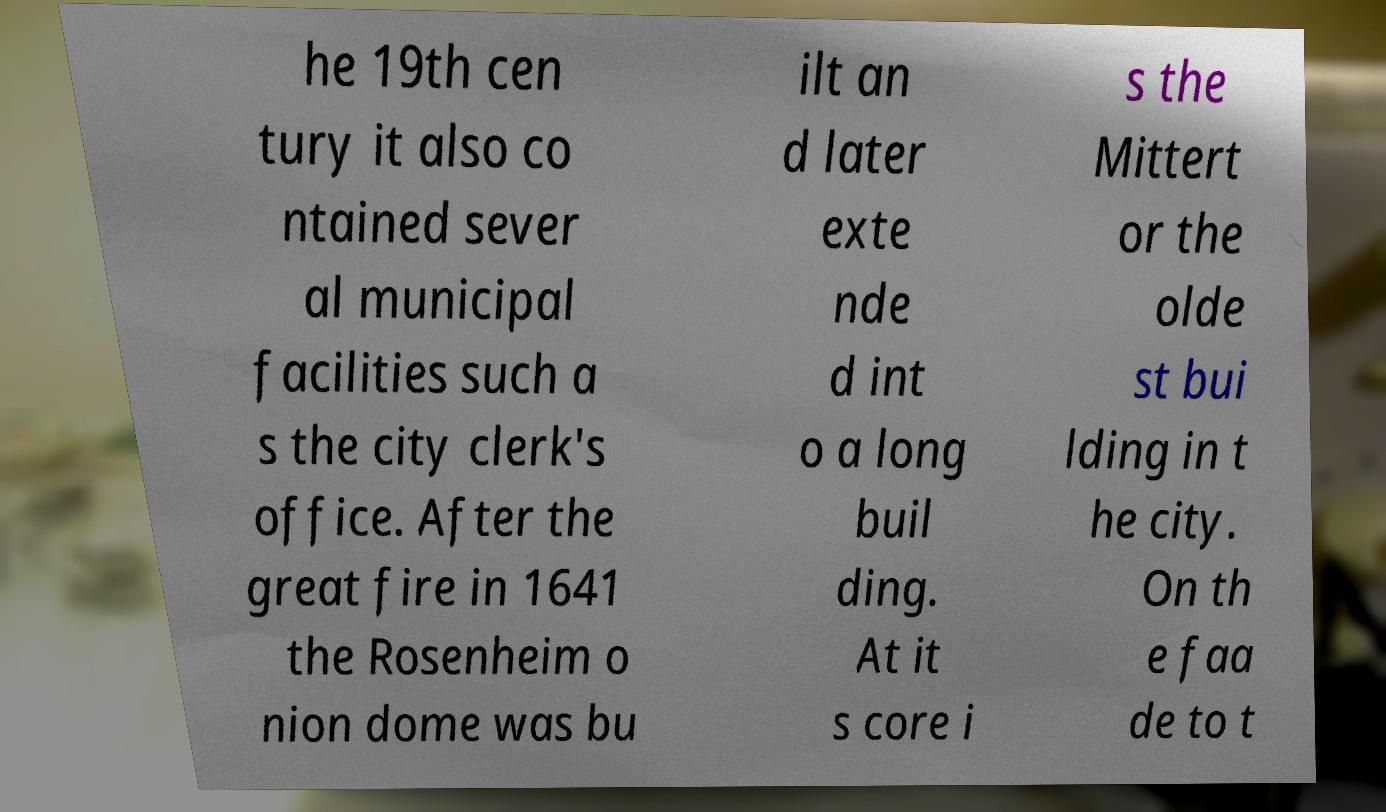For documentation purposes, I need the text within this image transcribed. Could you provide that? he 19th cen tury it also co ntained sever al municipal facilities such a s the city clerk's office. After the great fire in 1641 the Rosenheim o nion dome was bu ilt an d later exte nde d int o a long buil ding. At it s core i s the Mittert or the olde st bui lding in t he city. On th e faa de to t 